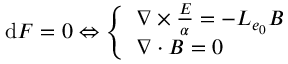Convert formula to latex. <formula><loc_0><loc_0><loc_500><loc_500>d F = 0 \Leftrightarrow \left \{ \begin{array} { l l } { \nabla \frac { E } { \alpha } = - L _ { e _ { 0 } } B } \\ { \nabla \cdot B = 0 } \end{array}</formula> 